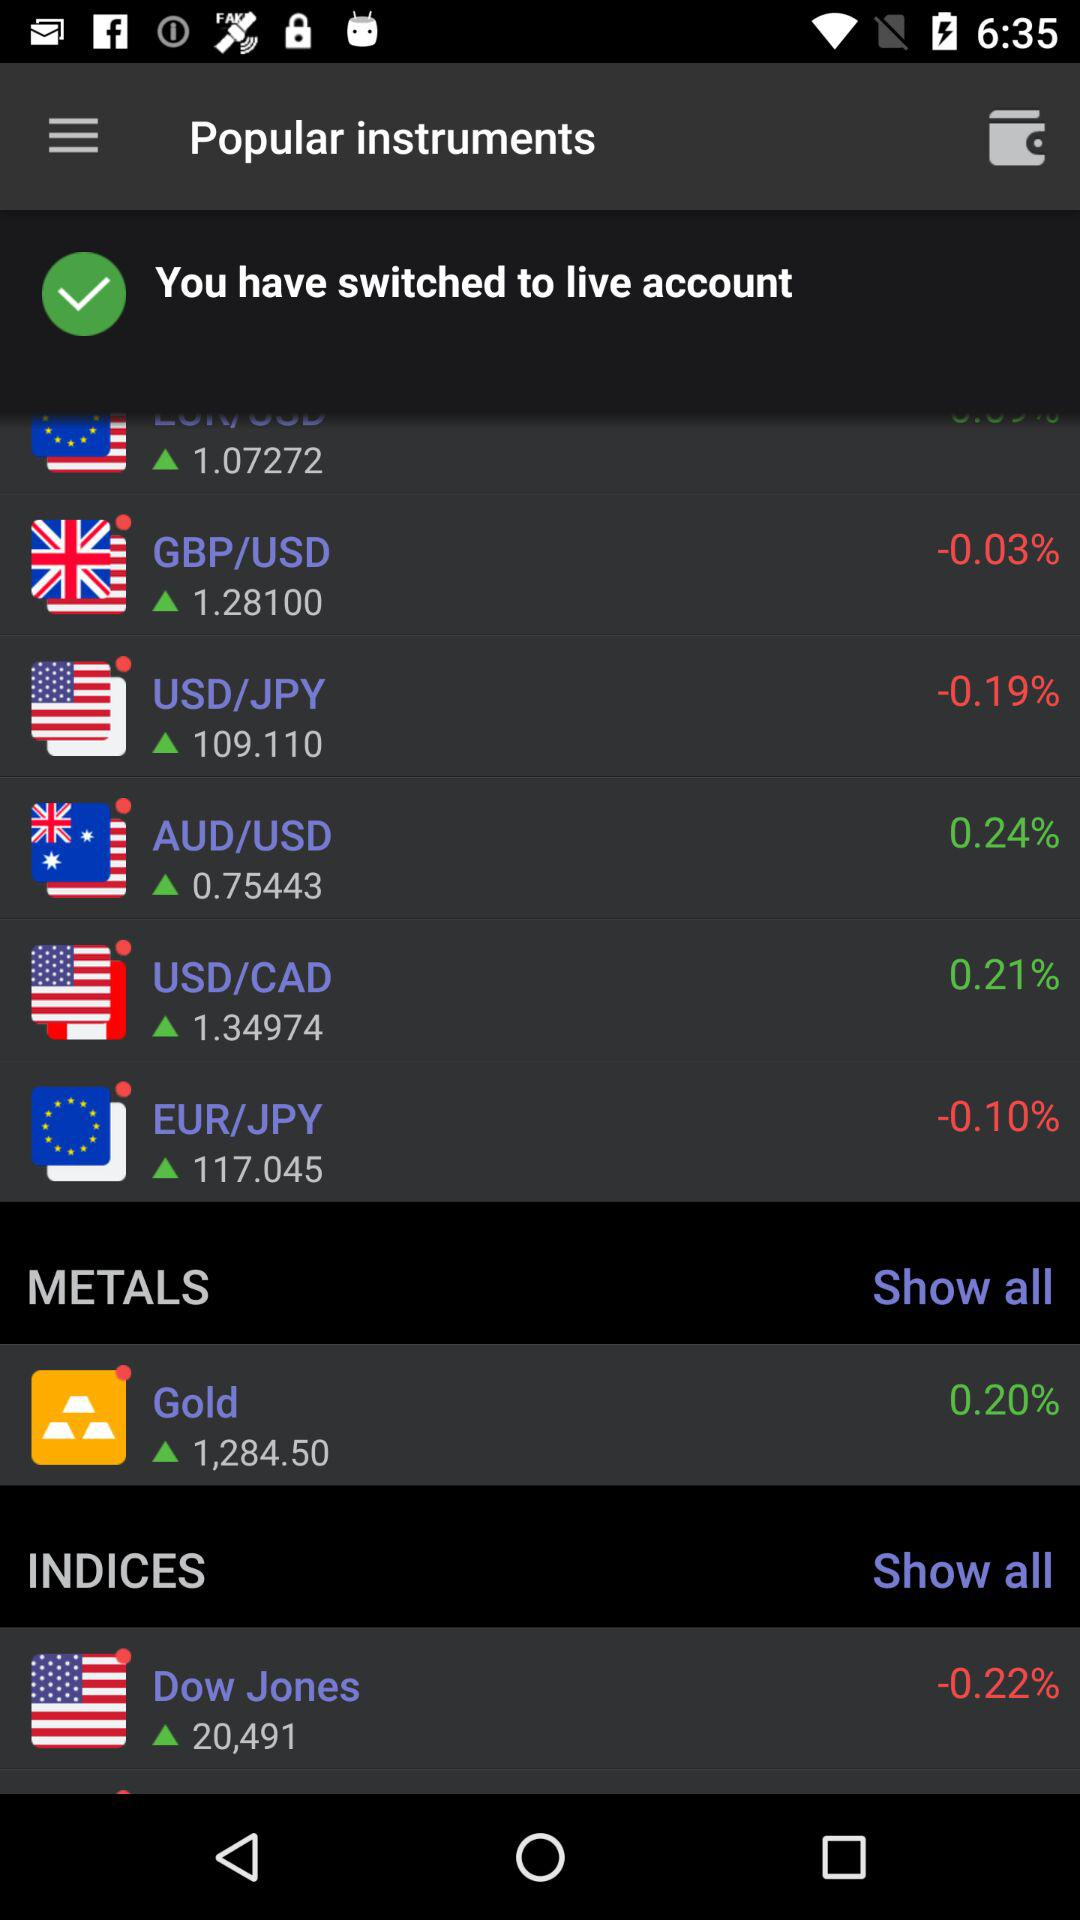How much has the GBP/USD decreased since last time?
Answer the question using a single word or phrase. -0.03% 